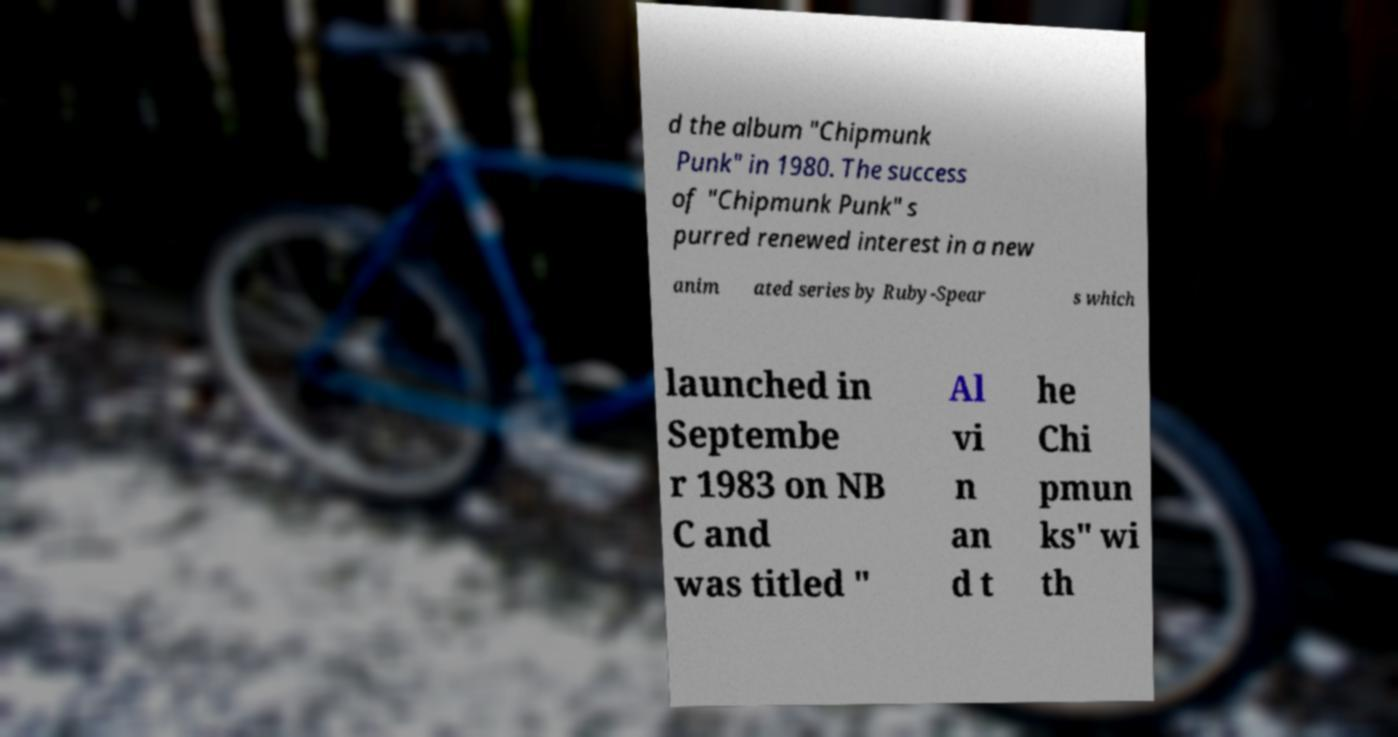Please read and relay the text visible in this image. What does it say? d the album "Chipmunk Punk" in 1980. The success of "Chipmunk Punk" s purred renewed interest in a new anim ated series by Ruby-Spear s which launched in Septembe r 1983 on NB C and was titled " Al vi n an d t he Chi pmun ks" wi th 